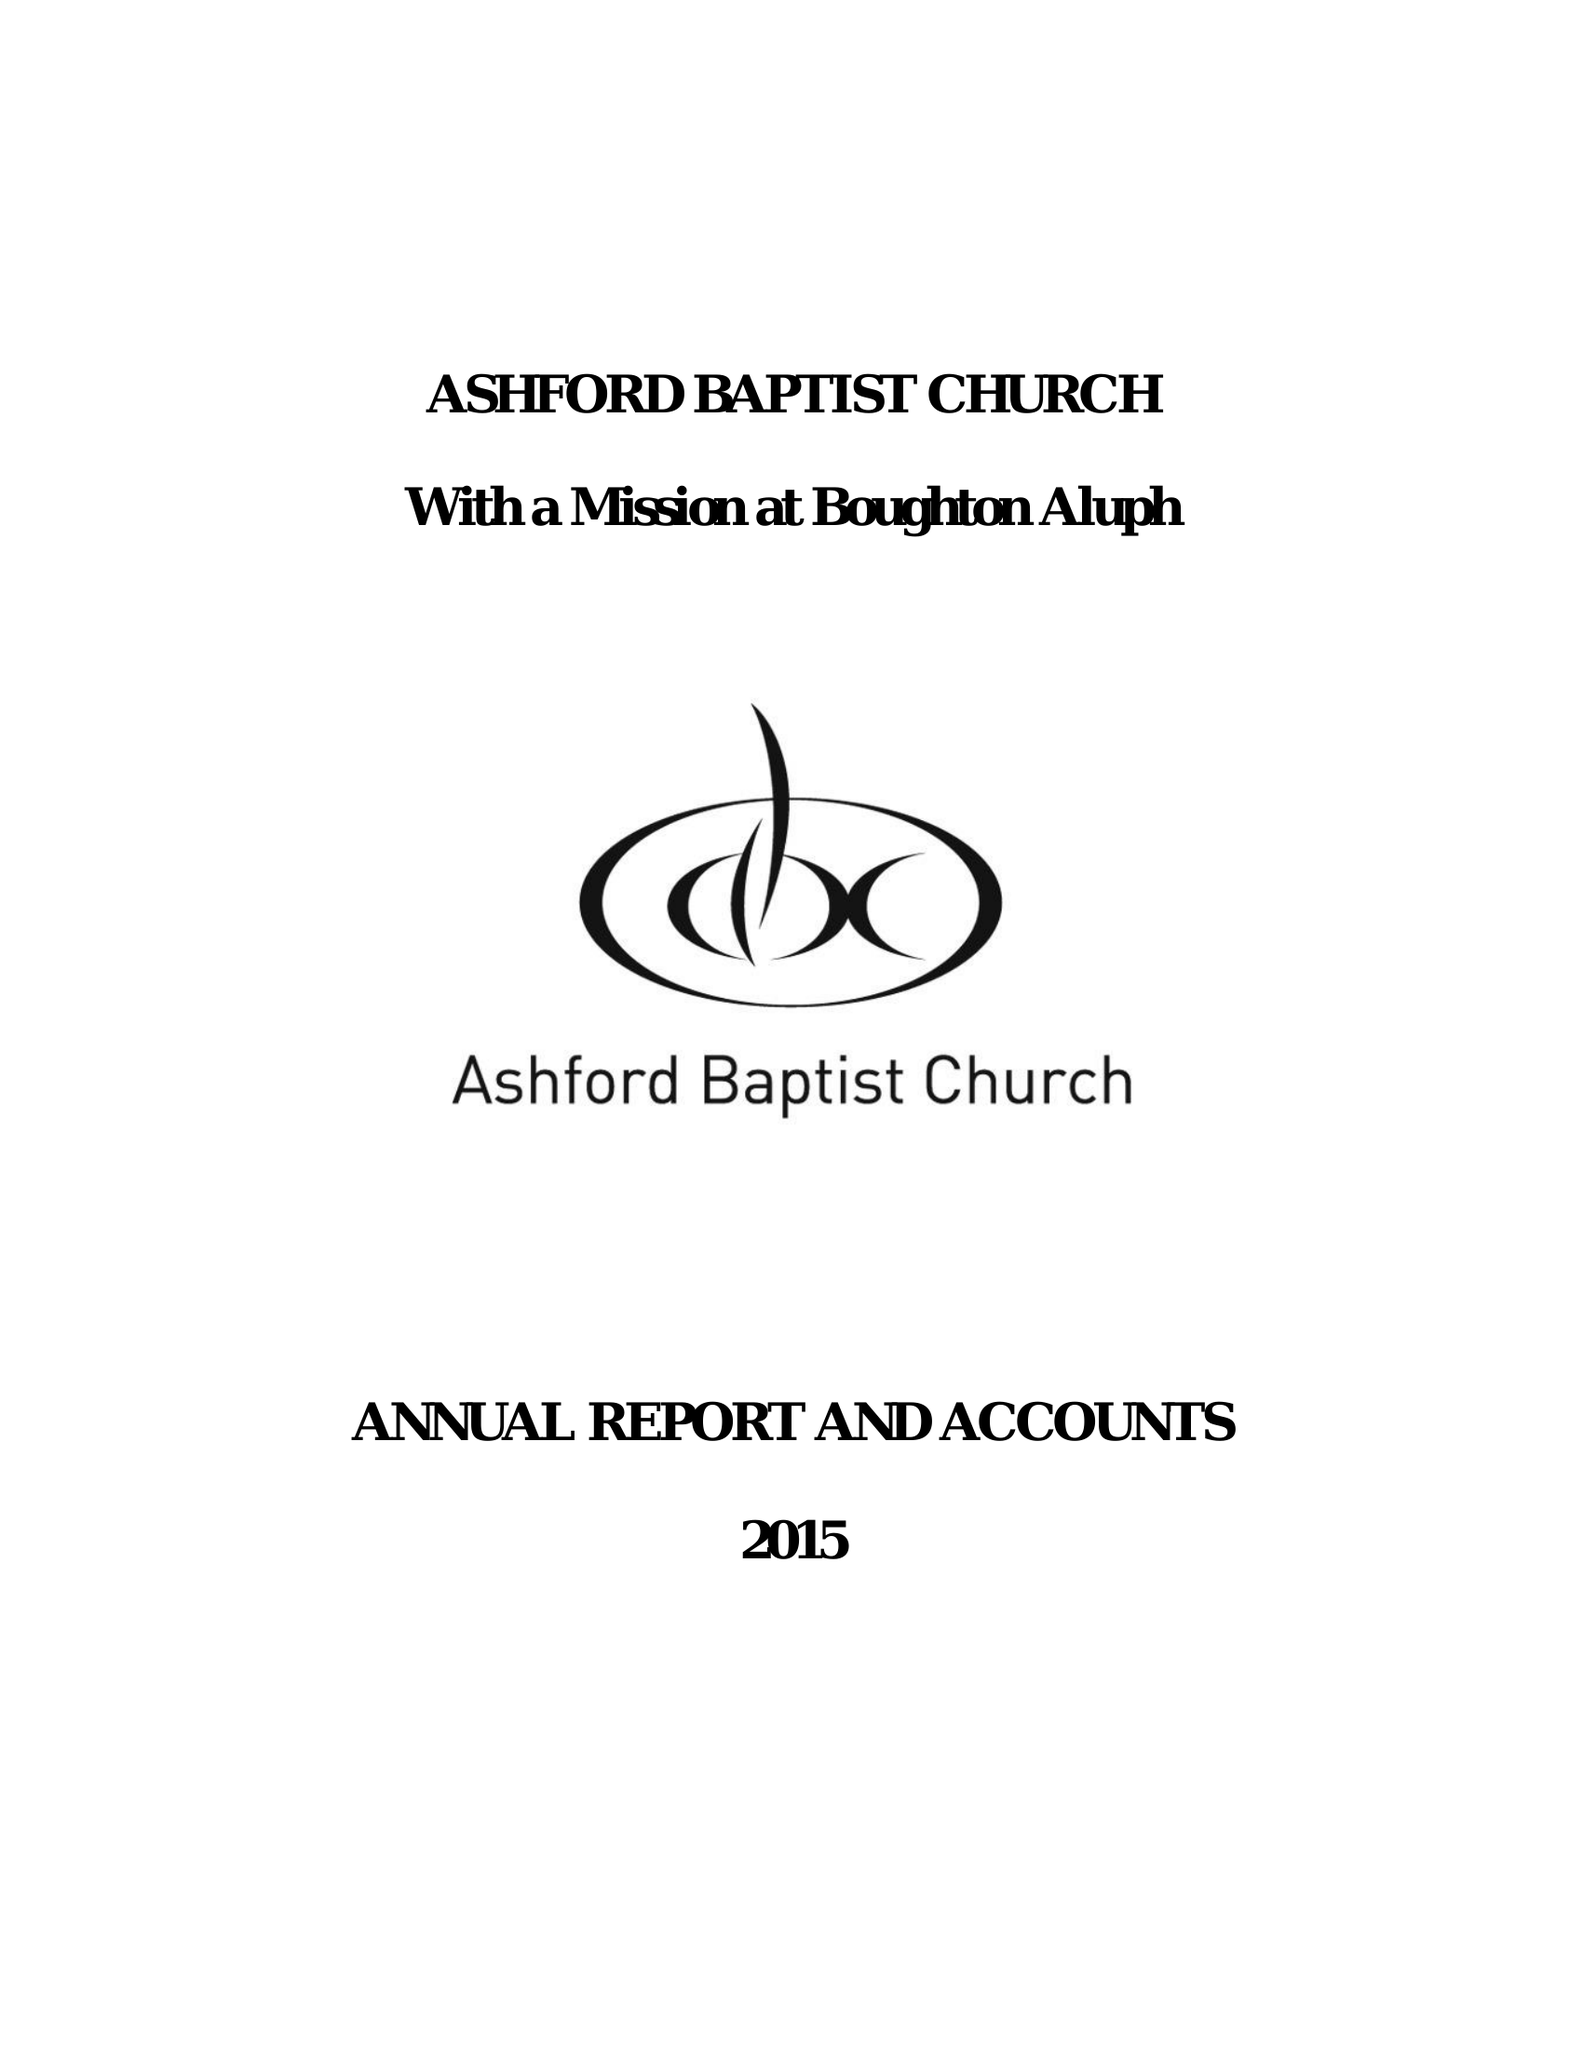What is the value for the spending_annually_in_british_pounds?
Answer the question using a single word or phrase. 204603.00 